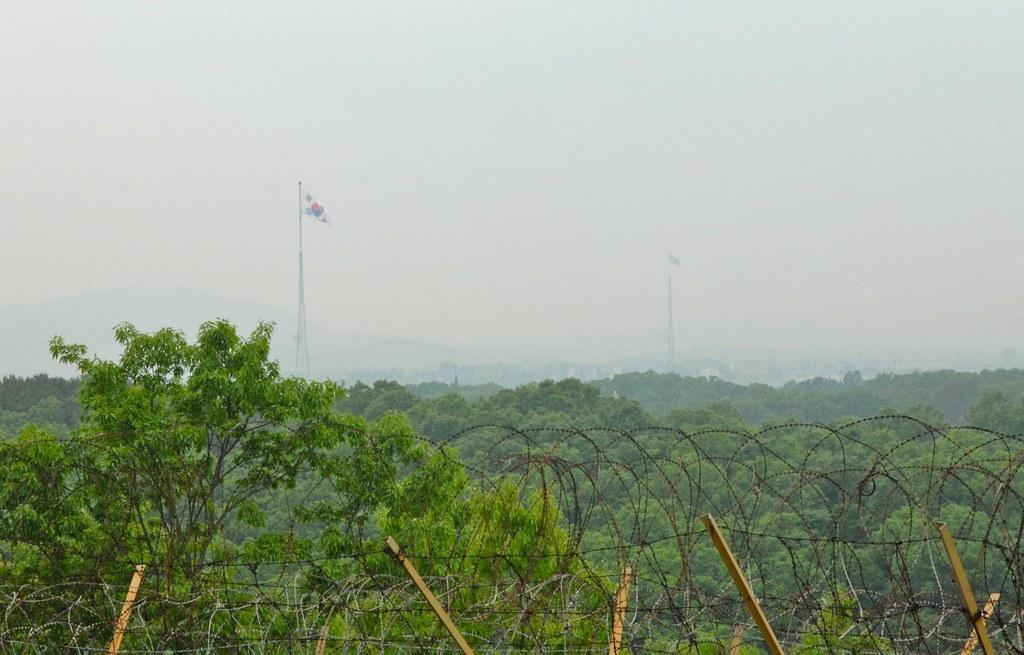Describe this image in one or two sentences. In this image I can see few trees, fencing and flags. The sky is in white color. 